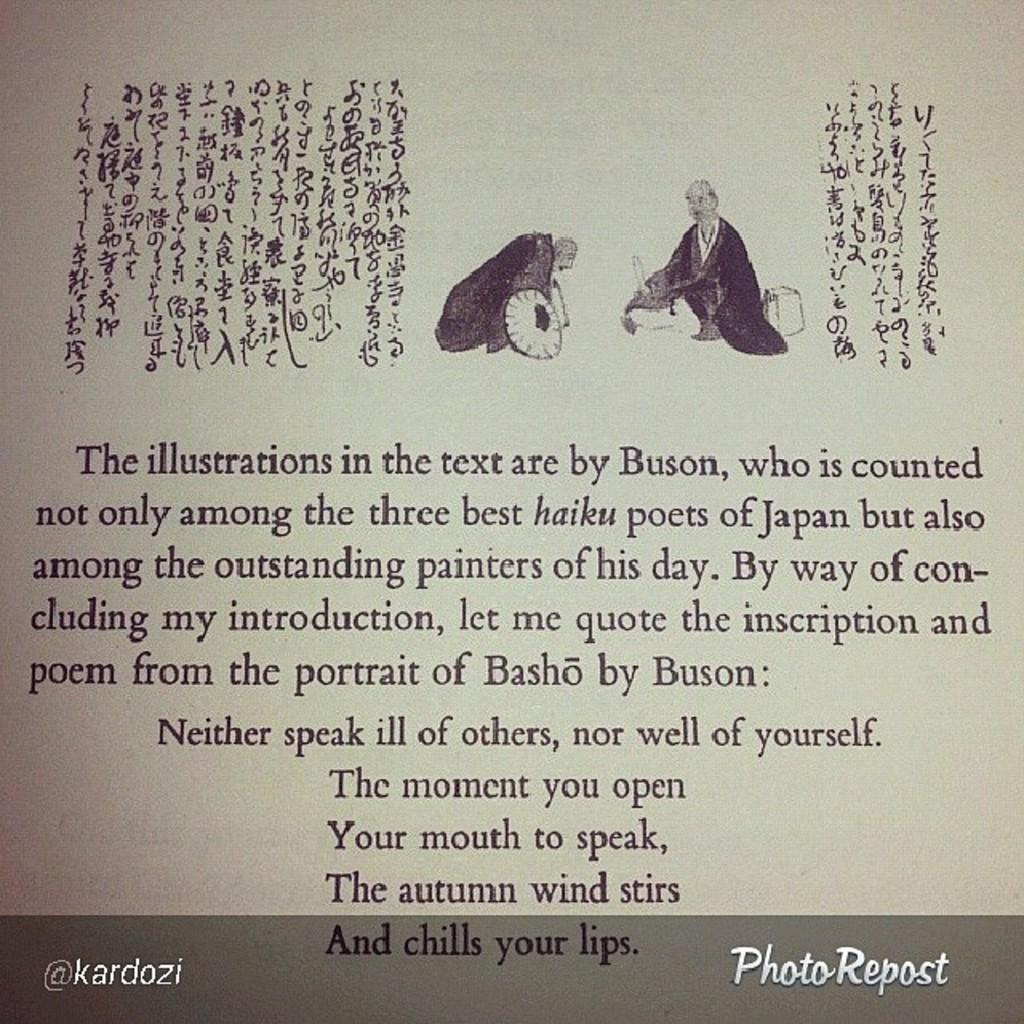Provide a one-sentence caption for the provided image. An introduction written for a book on haiku poets of Japan ends with a poem from The Portrait of Basho by Buson. 